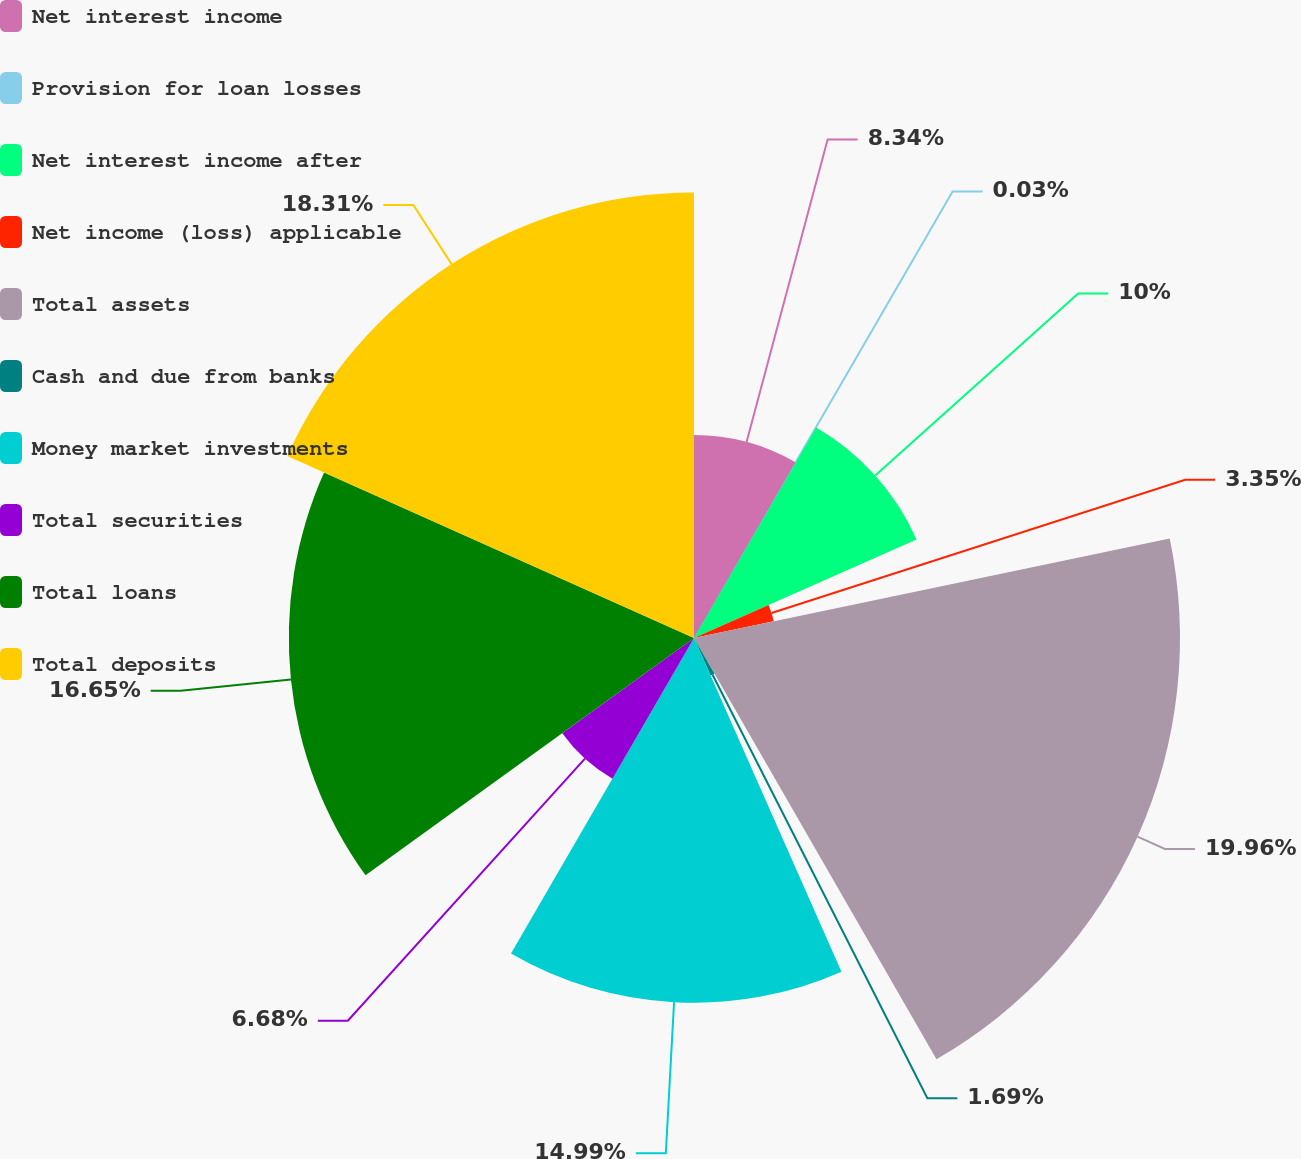Convert chart. <chart><loc_0><loc_0><loc_500><loc_500><pie_chart><fcel>Net interest income<fcel>Provision for loan losses<fcel>Net interest income after<fcel>Net income (loss) applicable<fcel>Total assets<fcel>Cash and due from banks<fcel>Money market investments<fcel>Total securities<fcel>Total loans<fcel>Total deposits<nl><fcel>8.34%<fcel>0.03%<fcel>10.0%<fcel>3.35%<fcel>19.97%<fcel>1.69%<fcel>14.99%<fcel>6.68%<fcel>16.65%<fcel>18.31%<nl></chart> 